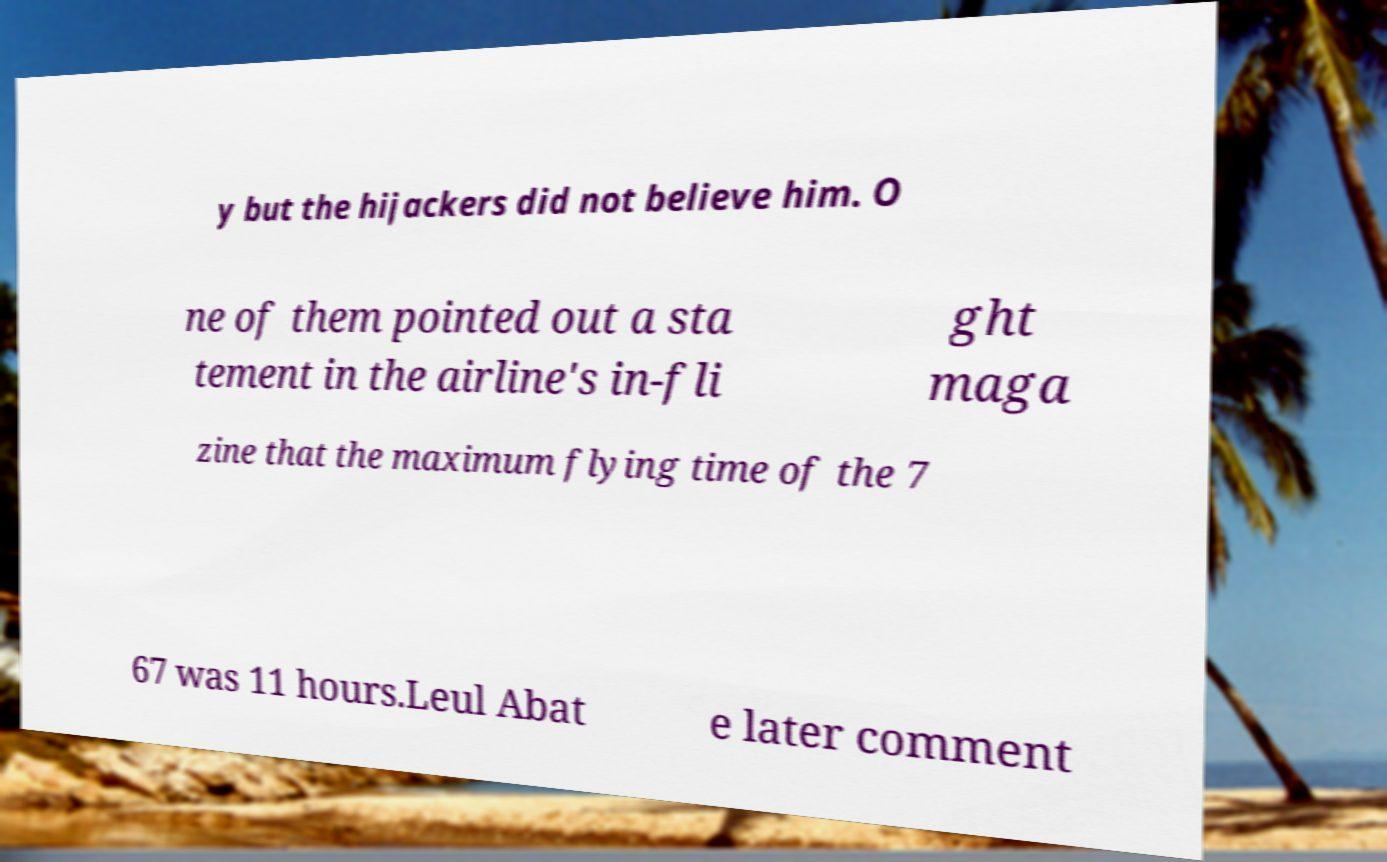Could you extract and type out the text from this image? y but the hijackers did not believe him. O ne of them pointed out a sta tement in the airline's in-fli ght maga zine that the maximum flying time of the 7 67 was 11 hours.Leul Abat e later comment 